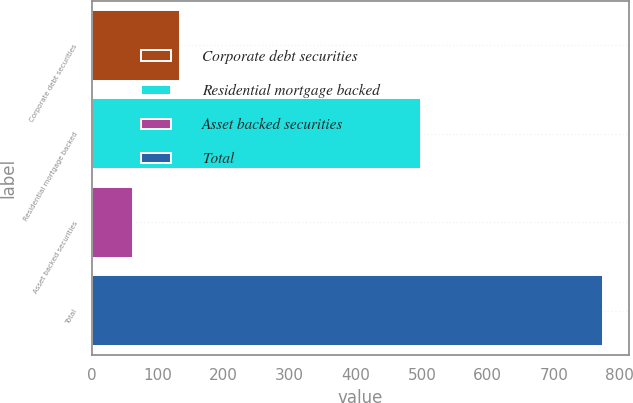Convert chart to OTSL. <chart><loc_0><loc_0><loc_500><loc_500><bar_chart><fcel>Corporate debt securities<fcel>Residential mortgage backed<fcel>Asset backed securities<fcel>Total<nl><fcel>133.3<fcel>498<fcel>62<fcel>775<nl></chart> 